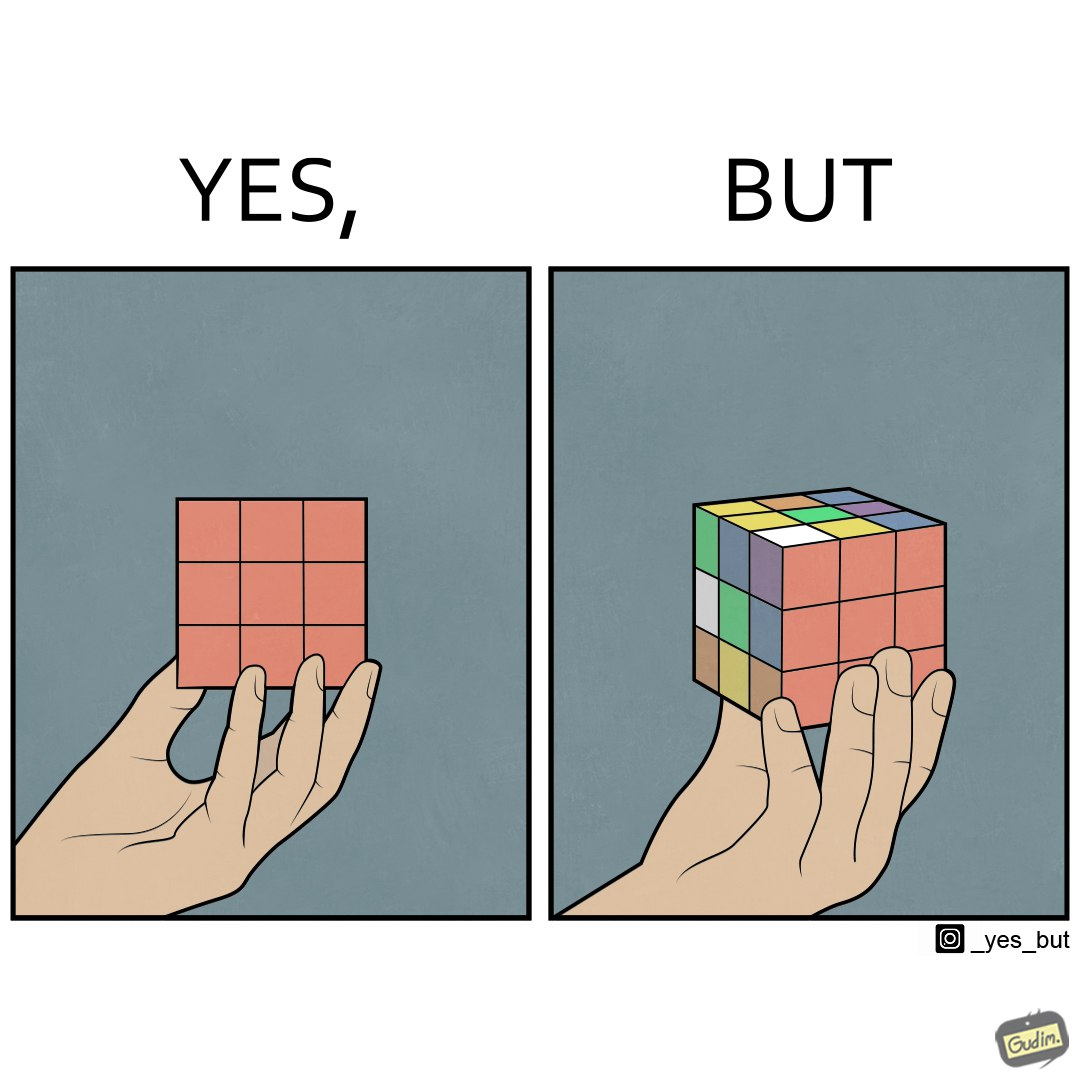What is shown in the left half versus the right half of this image? In the left part of the image: It is a hand holding a solved rubiks cube In the right part of the image: It is a hand holding a jumbled rubiks cube with only one side of it solved 